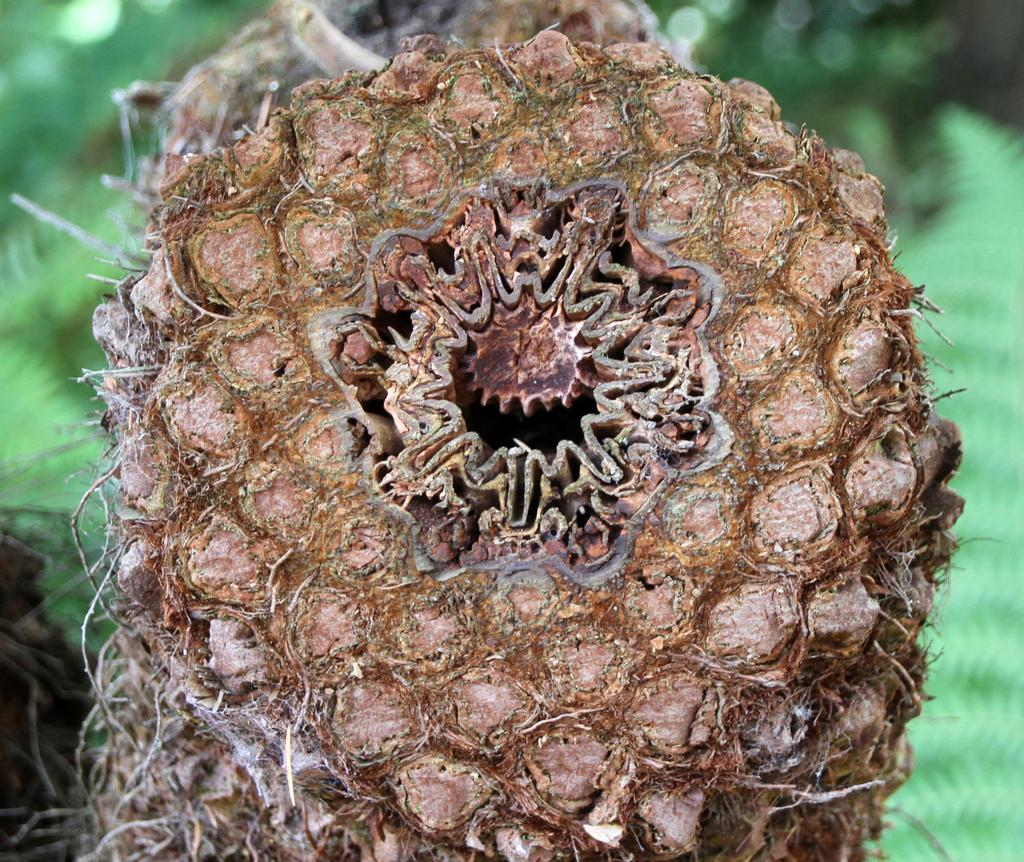What is the color of the main object in the image? The main object in the image is brown in color. Can you describe the objects in the background of the image? The objects in the background of the image are blurry and green in color. What is the rabbit thinking about in the image? There is no rabbit present in the image, so it is not possible to determine what the rabbit might be thinking. 